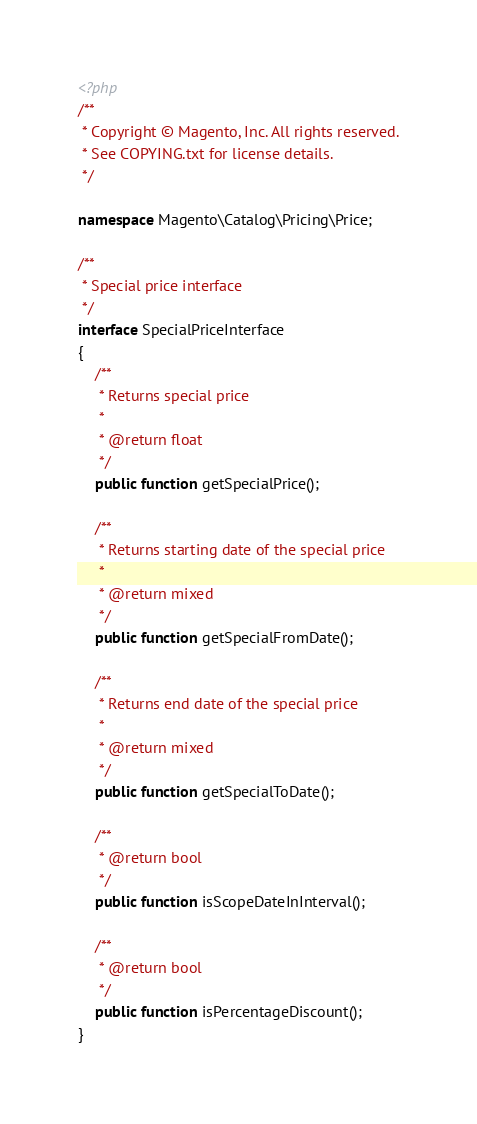Convert code to text. <code><loc_0><loc_0><loc_500><loc_500><_PHP_><?php
/**
 * Copyright © Magento, Inc. All rights reserved.
 * See COPYING.txt for license details.
 */

namespace Magento\Catalog\Pricing\Price;

/**
 * Special price interface
 */
interface SpecialPriceInterface
{
    /**
     * Returns special price
     *
     * @return float
     */
    public function getSpecialPrice();

    /**
     * Returns starting date of the special price
     *
     * @return mixed
     */
    public function getSpecialFromDate();

    /**
     * Returns end date of the special price
     *
     * @return mixed
     */
    public function getSpecialToDate();

    /**
     * @return bool
     */
    public function isScopeDateInInterval();

    /**
     * @return bool
     */
    public function isPercentageDiscount();
}
</code> 